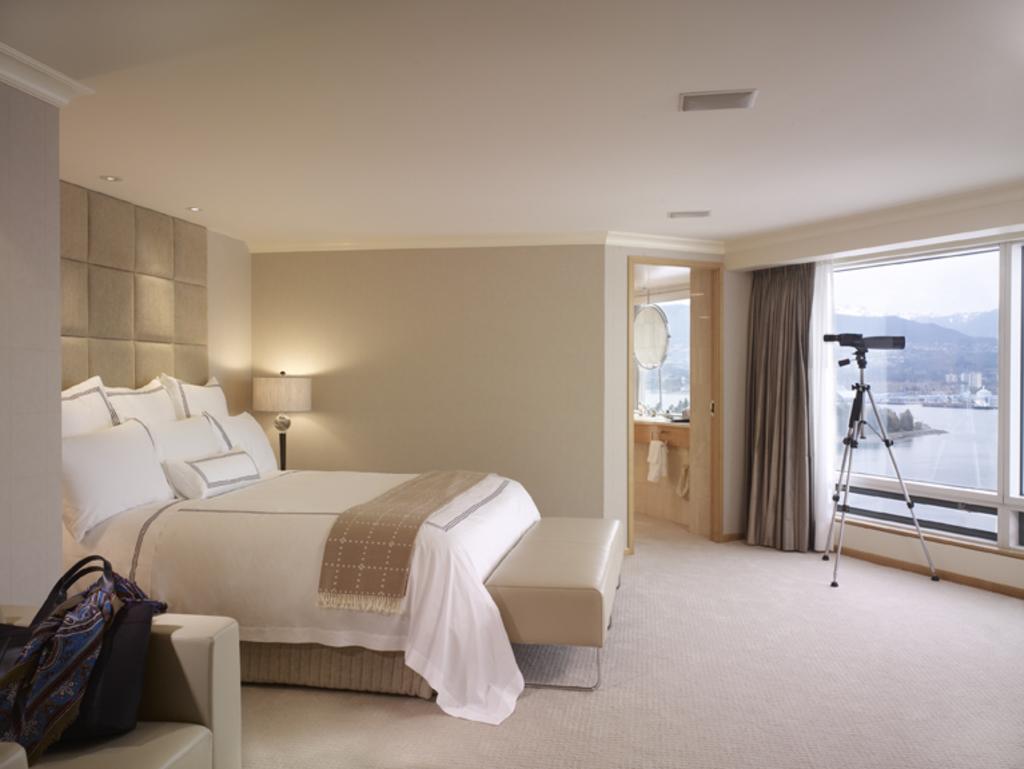How would you summarize this image in a sentence or two? In this image I can see a bed which has pillows, blanket and mattress. I can also see light lamp, a bag on the chair and lights on the ceiling. Here I can see windows, curtains and some other objects on the ground. 